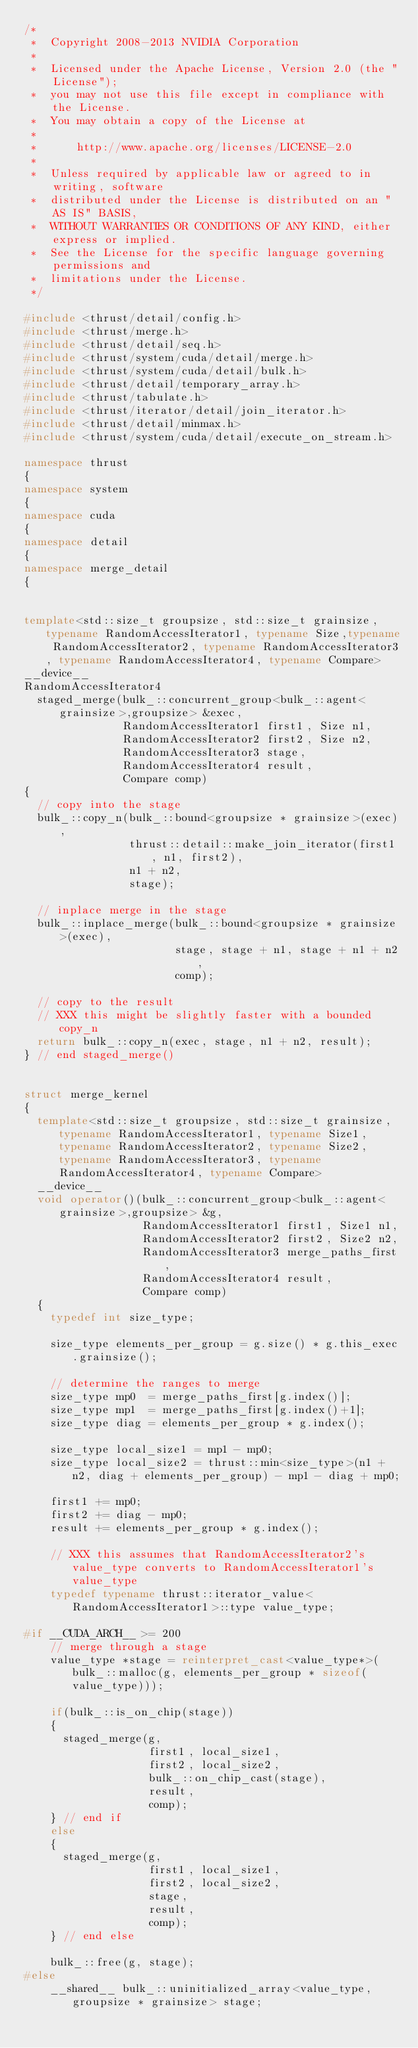Convert code to text. <code><loc_0><loc_0><loc_500><loc_500><_C++_>/*
 *  Copyright 2008-2013 NVIDIA Corporation
 *
 *  Licensed under the Apache License, Version 2.0 (the "License");
 *  you may not use this file except in compliance with the License.
 *  You may obtain a copy of the License at
 *
 *      http://www.apache.org/licenses/LICENSE-2.0
 *
 *  Unless required by applicable law or agreed to in writing, software
 *  distributed under the License is distributed on an "AS IS" BASIS,
 *  WITHOUT WARRANTIES OR CONDITIONS OF ANY KIND, either express or implied.
 *  See the License for the specific language governing permissions and
 *  limitations under the License.
 */

#include <thrust/detail/config.h>
#include <thrust/merge.h>
#include <thrust/detail/seq.h>
#include <thrust/system/cuda/detail/merge.h>
#include <thrust/system/cuda/detail/bulk.h>
#include <thrust/detail/temporary_array.h>
#include <thrust/tabulate.h>
#include <thrust/iterator/detail/join_iterator.h>
#include <thrust/detail/minmax.h>
#include <thrust/system/cuda/detail/execute_on_stream.h>

namespace thrust
{
namespace system
{
namespace cuda
{
namespace detail
{
namespace merge_detail
{


template<std::size_t groupsize, std::size_t grainsize, typename RandomAccessIterator1, typename Size,typename RandomAccessIterator2, typename RandomAccessIterator3, typename RandomAccessIterator4, typename Compare>
__device__
RandomAccessIterator4
  staged_merge(bulk_::concurrent_group<bulk_::agent<grainsize>,groupsize> &exec,
               RandomAccessIterator1 first1, Size n1,
               RandomAccessIterator2 first2, Size n2,
               RandomAccessIterator3 stage,
               RandomAccessIterator4 result,
               Compare comp)
{
  // copy into the stage
  bulk_::copy_n(bulk_::bound<groupsize * grainsize>(exec),
                thrust::detail::make_join_iterator(first1, n1, first2),
                n1 + n2,
                stage);

  // inplace merge in the stage
  bulk_::inplace_merge(bulk_::bound<groupsize * grainsize>(exec),
                       stage, stage + n1, stage + n1 + n2,
                       comp);
  
  // copy to the result
  // XXX this might be slightly faster with a bounded copy_n
  return bulk_::copy_n(exec, stage, n1 + n2, result);
} // end staged_merge()


struct merge_kernel
{
  template<std::size_t groupsize, std::size_t grainsize, typename RandomAccessIterator1, typename Size1, typename RandomAccessIterator2, typename Size2, typename RandomAccessIterator3, typename RandomAccessIterator4, typename Compare>
  __device__
  void operator()(bulk_::concurrent_group<bulk_::agent<grainsize>,groupsize> &g,
                  RandomAccessIterator1 first1, Size1 n1,
                  RandomAccessIterator2 first2, Size2 n2,
                  RandomAccessIterator3 merge_paths_first,
                  RandomAccessIterator4 result,
                  Compare comp)
  {
    typedef int size_type;

    size_type elements_per_group = g.size() * g.this_exec.grainsize();

    // determine the ranges to merge
    size_type mp0  = merge_paths_first[g.index()];
    size_type mp1  = merge_paths_first[g.index()+1];
    size_type diag = elements_per_group * g.index();

    size_type local_size1 = mp1 - mp0;
    size_type local_size2 = thrust::min<size_type>(n1 + n2, diag + elements_per_group) - mp1 - diag + mp0;

    first1 += mp0;
    first2 += diag - mp0;
    result += elements_per_group * g.index();

    // XXX this assumes that RandomAccessIterator2's value_type converts to RandomAccessIterator1's value_type
    typedef typename thrust::iterator_value<RandomAccessIterator1>::type value_type;

#if __CUDA_ARCH__ >= 200
    // merge through a stage
    value_type *stage = reinterpret_cast<value_type*>(bulk_::malloc(g, elements_per_group * sizeof(value_type)));

    if(bulk_::is_on_chip(stage))
    {
      staged_merge(g,
                   first1, local_size1,
                   first2, local_size2,
                   bulk_::on_chip_cast(stage),
                   result,
                   comp);
    } // end if
    else
    {
      staged_merge(g,
                   first1, local_size1,
                   first2, local_size2,
                   stage,
                   result,
                   comp);
    } // end else

    bulk_::free(g, stage);
#else
    __shared__ bulk_::uninitialized_array<value_type, groupsize * grainsize> stage;</code> 